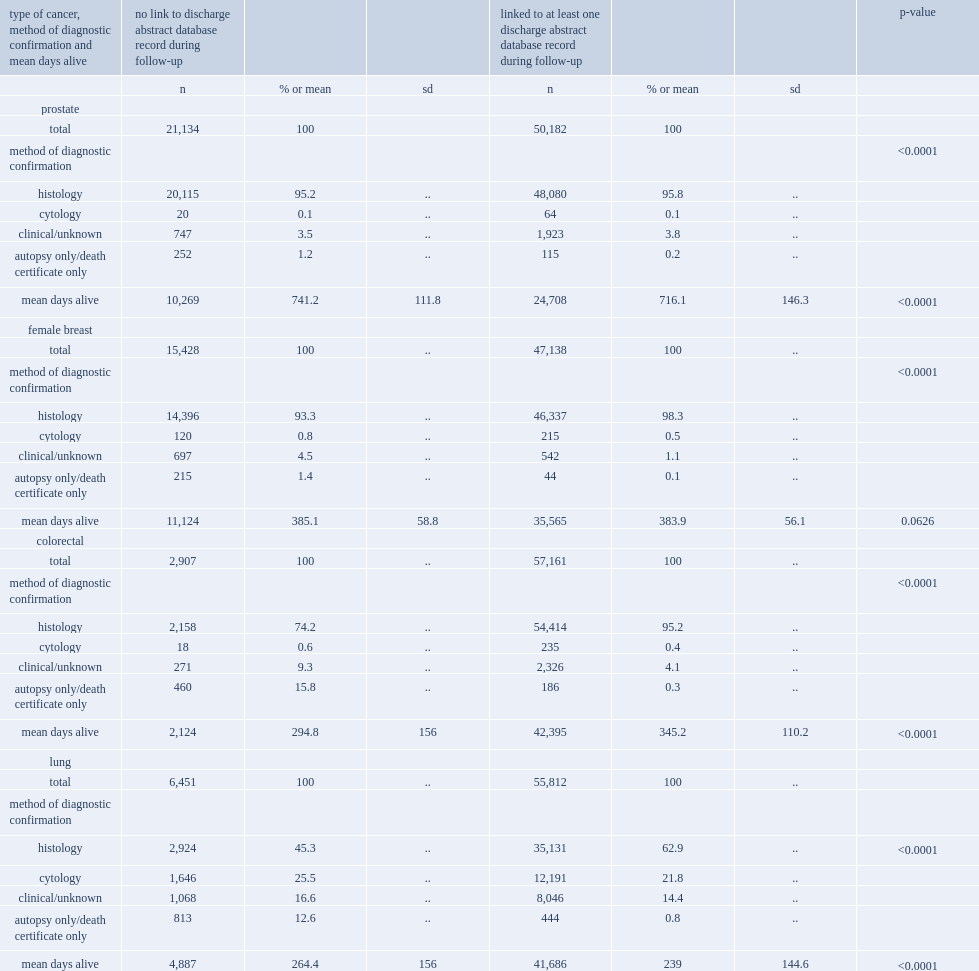What were the average numbers of days alive during follow-up for prostate cancers not linking to the dad and linked to at least one discharge abstract database record respectively? 741.2 716.1. For breast cancers,who were more likely to be histologically confirmed,those not linking to a dad record or those that linked ? Linked to at least one discharge abstract database record during follow-up. For colorectal cancers,who were more likely to be histologically confirmed ,those not linking to a dad record or those that linked? Linked to at least one discharge abstract database record during follow-up. For lung cancers ,who were more likely to be histologically confirmed ,those not linking to a dad record or those that linked? Linked to at least one discharge abstract database record during follow-up. 